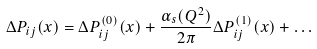Convert formula to latex. <formula><loc_0><loc_0><loc_500><loc_500>\Delta P _ { i j } ( x ) = \Delta P ^ { ( 0 ) } _ { i j } ( x ) + \frac { \alpha _ { s } ( Q ^ { 2 } ) } { 2 \pi } \Delta P ^ { ( 1 ) } _ { i j } ( x ) + \dots</formula> 